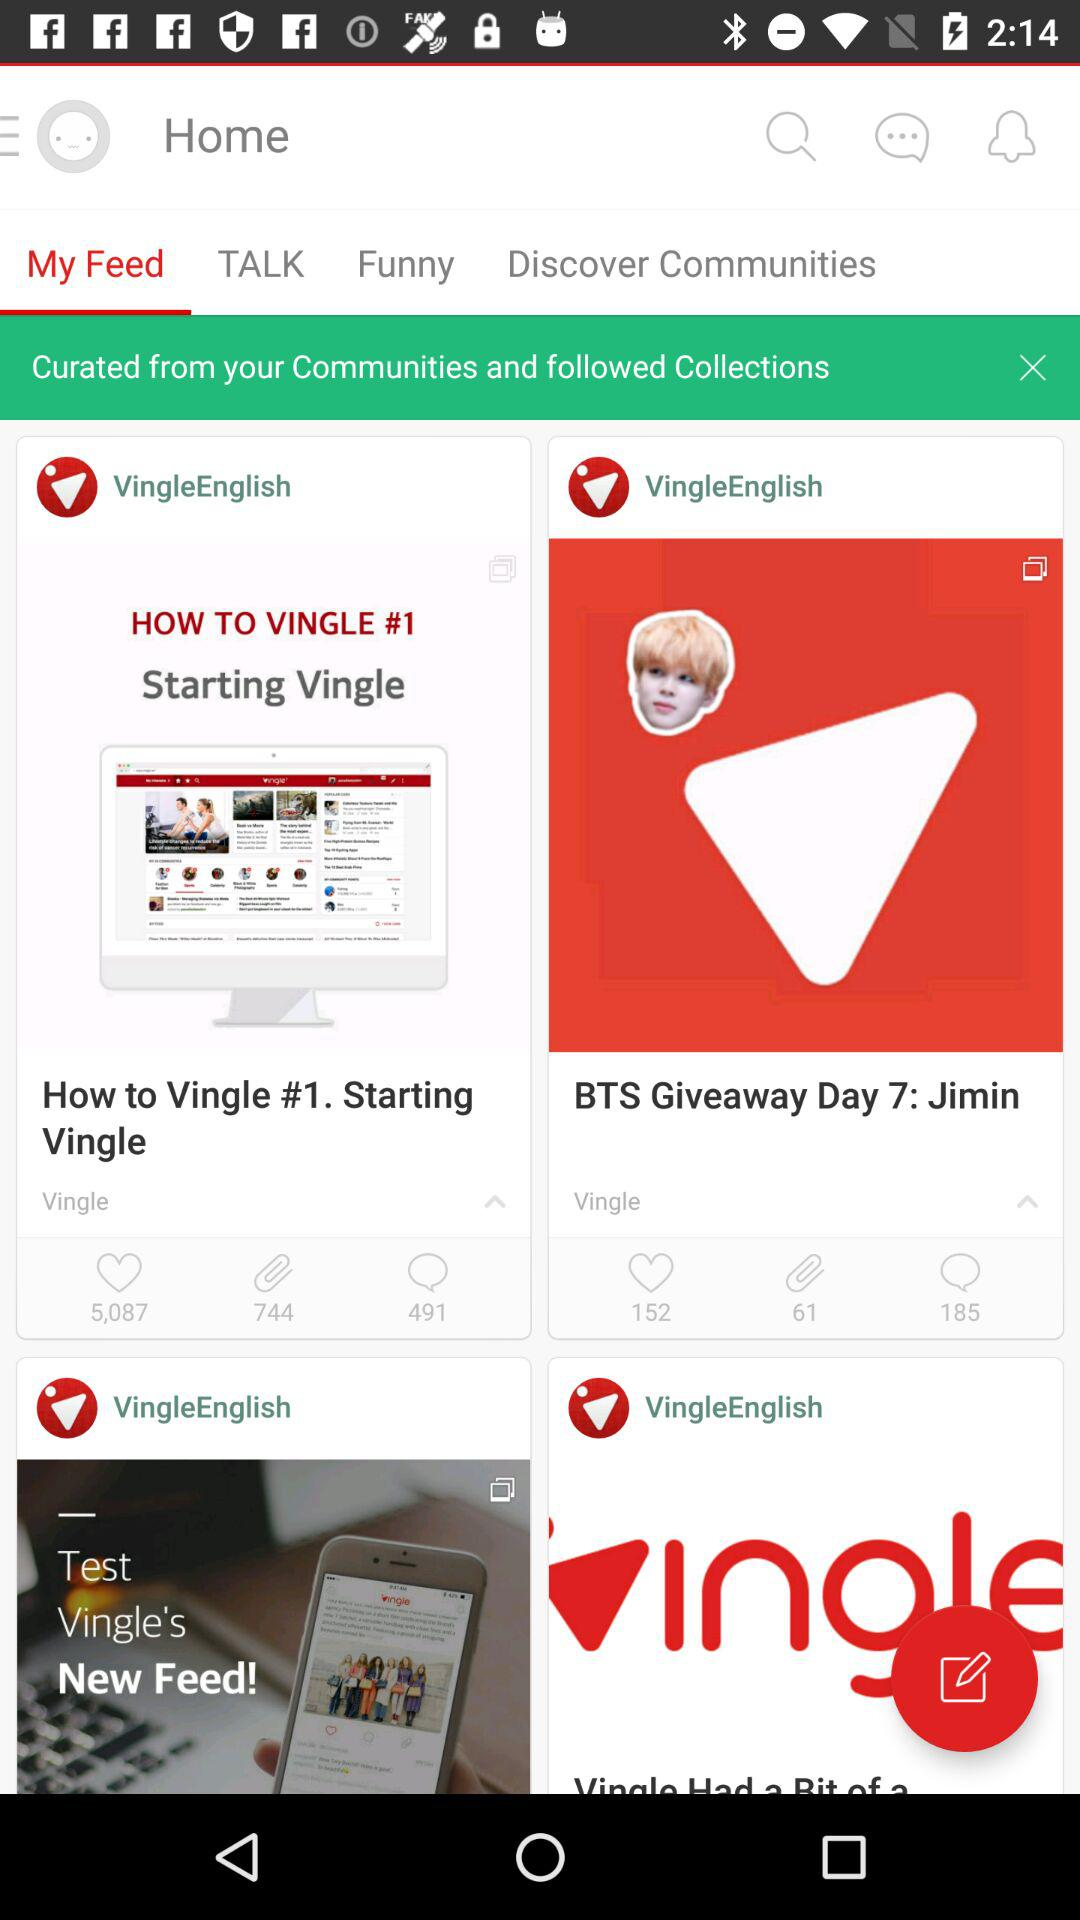What is the number of comments for the "BTS Giveaway Day 7: Jimin" post? The number of comments for the "BTS Giveaway Day 7: Jimin" post is 185. 